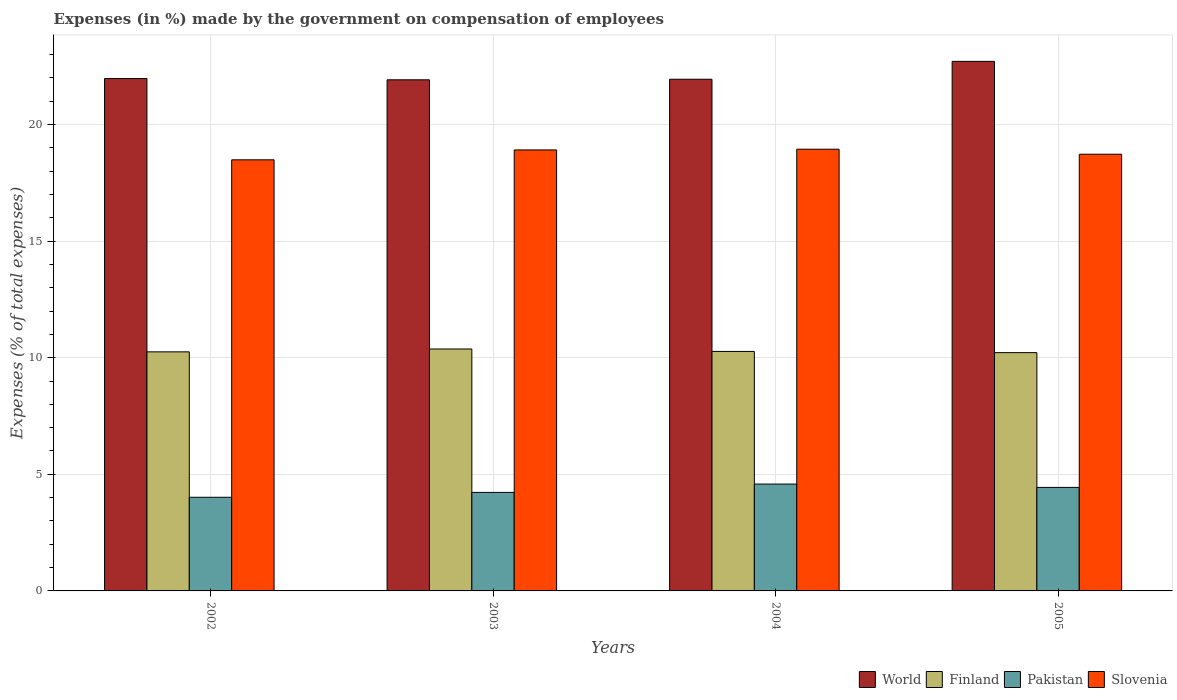How many different coloured bars are there?
Your answer should be compact. 4. Are the number of bars per tick equal to the number of legend labels?
Offer a very short reply. Yes. How many bars are there on the 4th tick from the right?
Offer a terse response. 4. What is the label of the 3rd group of bars from the left?
Keep it short and to the point. 2004. What is the percentage of expenses made by the government on compensation of employees in Finland in 2005?
Your answer should be compact. 10.22. Across all years, what is the maximum percentage of expenses made by the government on compensation of employees in Pakistan?
Give a very brief answer. 4.58. Across all years, what is the minimum percentage of expenses made by the government on compensation of employees in Slovenia?
Provide a succinct answer. 18.49. In which year was the percentage of expenses made by the government on compensation of employees in Finland minimum?
Offer a terse response. 2005. What is the total percentage of expenses made by the government on compensation of employees in Slovenia in the graph?
Your response must be concise. 75.06. What is the difference between the percentage of expenses made by the government on compensation of employees in Pakistan in 2003 and that in 2004?
Offer a terse response. -0.36. What is the difference between the percentage of expenses made by the government on compensation of employees in Pakistan in 2003 and the percentage of expenses made by the government on compensation of employees in Finland in 2005?
Offer a terse response. -5.99. What is the average percentage of expenses made by the government on compensation of employees in Pakistan per year?
Your answer should be compact. 4.32. In the year 2004, what is the difference between the percentage of expenses made by the government on compensation of employees in Slovenia and percentage of expenses made by the government on compensation of employees in Pakistan?
Your answer should be very brief. 14.36. What is the ratio of the percentage of expenses made by the government on compensation of employees in Slovenia in 2003 to that in 2004?
Offer a terse response. 1. Is the percentage of expenses made by the government on compensation of employees in Finland in 2004 less than that in 2005?
Your answer should be compact. No. Is the difference between the percentage of expenses made by the government on compensation of employees in Slovenia in 2003 and 2005 greater than the difference between the percentage of expenses made by the government on compensation of employees in Pakistan in 2003 and 2005?
Ensure brevity in your answer.  Yes. What is the difference between the highest and the second highest percentage of expenses made by the government on compensation of employees in Slovenia?
Your response must be concise. 0.03. What is the difference between the highest and the lowest percentage of expenses made by the government on compensation of employees in World?
Make the answer very short. 0.79. Is the sum of the percentage of expenses made by the government on compensation of employees in Pakistan in 2004 and 2005 greater than the maximum percentage of expenses made by the government on compensation of employees in Slovenia across all years?
Provide a short and direct response. No. Is it the case that in every year, the sum of the percentage of expenses made by the government on compensation of employees in Slovenia and percentage of expenses made by the government on compensation of employees in Finland is greater than the sum of percentage of expenses made by the government on compensation of employees in World and percentage of expenses made by the government on compensation of employees in Pakistan?
Provide a succinct answer. Yes. What does the 1st bar from the right in 2005 represents?
Your answer should be compact. Slovenia. Is it the case that in every year, the sum of the percentage of expenses made by the government on compensation of employees in World and percentage of expenses made by the government on compensation of employees in Pakistan is greater than the percentage of expenses made by the government on compensation of employees in Finland?
Make the answer very short. Yes. How many years are there in the graph?
Keep it short and to the point. 4. What is the difference between two consecutive major ticks on the Y-axis?
Ensure brevity in your answer.  5. Are the values on the major ticks of Y-axis written in scientific E-notation?
Your response must be concise. No. Does the graph contain grids?
Provide a succinct answer. Yes. Where does the legend appear in the graph?
Your answer should be very brief. Bottom right. How many legend labels are there?
Your answer should be compact. 4. What is the title of the graph?
Make the answer very short. Expenses (in %) made by the government on compensation of employees. Does "Kyrgyz Republic" appear as one of the legend labels in the graph?
Your answer should be compact. No. What is the label or title of the Y-axis?
Give a very brief answer. Expenses (% of total expenses). What is the Expenses (% of total expenses) in World in 2002?
Keep it short and to the point. 21.97. What is the Expenses (% of total expenses) in Finland in 2002?
Offer a very short reply. 10.25. What is the Expenses (% of total expenses) in Pakistan in 2002?
Offer a very short reply. 4.02. What is the Expenses (% of total expenses) in Slovenia in 2002?
Make the answer very short. 18.49. What is the Expenses (% of total expenses) of World in 2003?
Offer a terse response. 21.92. What is the Expenses (% of total expenses) in Finland in 2003?
Keep it short and to the point. 10.37. What is the Expenses (% of total expenses) in Pakistan in 2003?
Ensure brevity in your answer.  4.22. What is the Expenses (% of total expenses) of Slovenia in 2003?
Your response must be concise. 18.91. What is the Expenses (% of total expenses) of World in 2004?
Keep it short and to the point. 21.94. What is the Expenses (% of total expenses) of Finland in 2004?
Provide a succinct answer. 10.27. What is the Expenses (% of total expenses) of Pakistan in 2004?
Give a very brief answer. 4.58. What is the Expenses (% of total expenses) of Slovenia in 2004?
Your answer should be compact. 18.94. What is the Expenses (% of total expenses) of World in 2005?
Provide a succinct answer. 22.71. What is the Expenses (% of total expenses) in Finland in 2005?
Offer a terse response. 10.22. What is the Expenses (% of total expenses) of Pakistan in 2005?
Your answer should be compact. 4.44. What is the Expenses (% of total expenses) in Slovenia in 2005?
Give a very brief answer. 18.73. Across all years, what is the maximum Expenses (% of total expenses) of World?
Offer a very short reply. 22.71. Across all years, what is the maximum Expenses (% of total expenses) in Finland?
Offer a very short reply. 10.37. Across all years, what is the maximum Expenses (% of total expenses) of Pakistan?
Your answer should be compact. 4.58. Across all years, what is the maximum Expenses (% of total expenses) in Slovenia?
Offer a very short reply. 18.94. Across all years, what is the minimum Expenses (% of total expenses) in World?
Give a very brief answer. 21.92. Across all years, what is the minimum Expenses (% of total expenses) of Finland?
Offer a very short reply. 10.22. Across all years, what is the minimum Expenses (% of total expenses) of Pakistan?
Offer a very short reply. 4.02. Across all years, what is the minimum Expenses (% of total expenses) in Slovenia?
Make the answer very short. 18.49. What is the total Expenses (% of total expenses) of World in the graph?
Make the answer very short. 88.53. What is the total Expenses (% of total expenses) of Finland in the graph?
Ensure brevity in your answer.  41.11. What is the total Expenses (% of total expenses) of Pakistan in the graph?
Your answer should be very brief. 17.26. What is the total Expenses (% of total expenses) in Slovenia in the graph?
Make the answer very short. 75.06. What is the difference between the Expenses (% of total expenses) of World in 2002 and that in 2003?
Provide a short and direct response. 0.06. What is the difference between the Expenses (% of total expenses) of Finland in 2002 and that in 2003?
Make the answer very short. -0.12. What is the difference between the Expenses (% of total expenses) in Pakistan in 2002 and that in 2003?
Keep it short and to the point. -0.21. What is the difference between the Expenses (% of total expenses) of Slovenia in 2002 and that in 2003?
Provide a succinct answer. -0.42. What is the difference between the Expenses (% of total expenses) of World in 2002 and that in 2004?
Make the answer very short. 0.03. What is the difference between the Expenses (% of total expenses) of Finland in 2002 and that in 2004?
Offer a very short reply. -0.02. What is the difference between the Expenses (% of total expenses) of Pakistan in 2002 and that in 2004?
Offer a very short reply. -0.57. What is the difference between the Expenses (% of total expenses) in Slovenia in 2002 and that in 2004?
Provide a short and direct response. -0.45. What is the difference between the Expenses (% of total expenses) of World in 2002 and that in 2005?
Your answer should be compact. -0.74. What is the difference between the Expenses (% of total expenses) of Finland in 2002 and that in 2005?
Your answer should be very brief. 0.03. What is the difference between the Expenses (% of total expenses) in Pakistan in 2002 and that in 2005?
Your answer should be very brief. -0.42. What is the difference between the Expenses (% of total expenses) in Slovenia in 2002 and that in 2005?
Your answer should be very brief. -0.24. What is the difference between the Expenses (% of total expenses) of World in 2003 and that in 2004?
Give a very brief answer. -0.02. What is the difference between the Expenses (% of total expenses) of Finland in 2003 and that in 2004?
Provide a succinct answer. 0.11. What is the difference between the Expenses (% of total expenses) of Pakistan in 2003 and that in 2004?
Provide a succinct answer. -0.36. What is the difference between the Expenses (% of total expenses) of Slovenia in 2003 and that in 2004?
Keep it short and to the point. -0.03. What is the difference between the Expenses (% of total expenses) in World in 2003 and that in 2005?
Ensure brevity in your answer.  -0.79. What is the difference between the Expenses (% of total expenses) of Finland in 2003 and that in 2005?
Make the answer very short. 0.16. What is the difference between the Expenses (% of total expenses) in Pakistan in 2003 and that in 2005?
Give a very brief answer. -0.21. What is the difference between the Expenses (% of total expenses) of Slovenia in 2003 and that in 2005?
Give a very brief answer. 0.18. What is the difference between the Expenses (% of total expenses) of World in 2004 and that in 2005?
Your response must be concise. -0.77. What is the difference between the Expenses (% of total expenses) of Finland in 2004 and that in 2005?
Ensure brevity in your answer.  0.05. What is the difference between the Expenses (% of total expenses) in Pakistan in 2004 and that in 2005?
Your response must be concise. 0.14. What is the difference between the Expenses (% of total expenses) of Slovenia in 2004 and that in 2005?
Your response must be concise. 0.21. What is the difference between the Expenses (% of total expenses) in World in 2002 and the Expenses (% of total expenses) in Finland in 2003?
Keep it short and to the point. 11.6. What is the difference between the Expenses (% of total expenses) of World in 2002 and the Expenses (% of total expenses) of Pakistan in 2003?
Offer a terse response. 17.75. What is the difference between the Expenses (% of total expenses) in World in 2002 and the Expenses (% of total expenses) in Slovenia in 2003?
Give a very brief answer. 3.06. What is the difference between the Expenses (% of total expenses) of Finland in 2002 and the Expenses (% of total expenses) of Pakistan in 2003?
Ensure brevity in your answer.  6.03. What is the difference between the Expenses (% of total expenses) in Finland in 2002 and the Expenses (% of total expenses) in Slovenia in 2003?
Offer a very short reply. -8.66. What is the difference between the Expenses (% of total expenses) in Pakistan in 2002 and the Expenses (% of total expenses) in Slovenia in 2003?
Your answer should be very brief. -14.89. What is the difference between the Expenses (% of total expenses) of World in 2002 and the Expenses (% of total expenses) of Finland in 2004?
Keep it short and to the point. 11.7. What is the difference between the Expenses (% of total expenses) of World in 2002 and the Expenses (% of total expenses) of Pakistan in 2004?
Offer a very short reply. 17.39. What is the difference between the Expenses (% of total expenses) of World in 2002 and the Expenses (% of total expenses) of Slovenia in 2004?
Offer a terse response. 3.03. What is the difference between the Expenses (% of total expenses) in Finland in 2002 and the Expenses (% of total expenses) in Pakistan in 2004?
Give a very brief answer. 5.67. What is the difference between the Expenses (% of total expenses) of Finland in 2002 and the Expenses (% of total expenses) of Slovenia in 2004?
Offer a very short reply. -8.69. What is the difference between the Expenses (% of total expenses) in Pakistan in 2002 and the Expenses (% of total expenses) in Slovenia in 2004?
Ensure brevity in your answer.  -14.92. What is the difference between the Expenses (% of total expenses) of World in 2002 and the Expenses (% of total expenses) of Finland in 2005?
Ensure brevity in your answer.  11.75. What is the difference between the Expenses (% of total expenses) in World in 2002 and the Expenses (% of total expenses) in Pakistan in 2005?
Provide a succinct answer. 17.53. What is the difference between the Expenses (% of total expenses) in World in 2002 and the Expenses (% of total expenses) in Slovenia in 2005?
Your answer should be very brief. 3.25. What is the difference between the Expenses (% of total expenses) of Finland in 2002 and the Expenses (% of total expenses) of Pakistan in 2005?
Offer a very short reply. 5.81. What is the difference between the Expenses (% of total expenses) of Finland in 2002 and the Expenses (% of total expenses) of Slovenia in 2005?
Provide a succinct answer. -8.47. What is the difference between the Expenses (% of total expenses) in Pakistan in 2002 and the Expenses (% of total expenses) in Slovenia in 2005?
Your answer should be very brief. -14.71. What is the difference between the Expenses (% of total expenses) of World in 2003 and the Expenses (% of total expenses) of Finland in 2004?
Provide a short and direct response. 11.65. What is the difference between the Expenses (% of total expenses) in World in 2003 and the Expenses (% of total expenses) in Pakistan in 2004?
Ensure brevity in your answer.  17.33. What is the difference between the Expenses (% of total expenses) in World in 2003 and the Expenses (% of total expenses) in Slovenia in 2004?
Offer a terse response. 2.98. What is the difference between the Expenses (% of total expenses) of Finland in 2003 and the Expenses (% of total expenses) of Pakistan in 2004?
Provide a succinct answer. 5.79. What is the difference between the Expenses (% of total expenses) in Finland in 2003 and the Expenses (% of total expenses) in Slovenia in 2004?
Offer a terse response. -8.57. What is the difference between the Expenses (% of total expenses) in Pakistan in 2003 and the Expenses (% of total expenses) in Slovenia in 2004?
Offer a very short reply. -14.72. What is the difference between the Expenses (% of total expenses) of World in 2003 and the Expenses (% of total expenses) of Finland in 2005?
Offer a terse response. 11.7. What is the difference between the Expenses (% of total expenses) in World in 2003 and the Expenses (% of total expenses) in Pakistan in 2005?
Provide a succinct answer. 17.48. What is the difference between the Expenses (% of total expenses) of World in 2003 and the Expenses (% of total expenses) of Slovenia in 2005?
Provide a short and direct response. 3.19. What is the difference between the Expenses (% of total expenses) in Finland in 2003 and the Expenses (% of total expenses) in Pakistan in 2005?
Your answer should be compact. 5.94. What is the difference between the Expenses (% of total expenses) in Finland in 2003 and the Expenses (% of total expenses) in Slovenia in 2005?
Provide a succinct answer. -8.35. What is the difference between the Expenses (% of total expenses) in Pakistan in 2003 and the Expenses (% of total expenses) in Slovenia in 2005?
Offer a very short reply. -14.5. What is the difference between the Expenses (% of total expenses) in World in 2004 and the Expenses (% of total expenses) in Finland in 2005?
Provide a short and direct response. 11.72. What is the difference between the Expenses (% of total expenses) in World in 2004 and the Expenses (% of total expenses) in Pakistan in 2005?
Provide a succinct answer. 17.5. What is the difference between the Expenses (% of total expenses) of World in 2004 and the Expenses (% of total expenses) of Slovenia in 2005?
Ensure brevity in your answer.  3.21. What is the difference between the Expenses (% of total expenses) in Finland in 2004 and the Expenses (% of total expenses) in Pakistan in 2005?
Your answer should be compact. 5.83. What is the difference between the Expenses (% of total expenses) of Finland in 2004 and the Expenses (% of total expenses) of Slovenia in 2005?
Offer a very short reply. -8.46. What is the difference between the Expenses (% of total expenses) in Pakistan in 2004 and the Expenses (% of total expenses) in Slovenia in 2005?
Your answer should be very brief. -14.14. What is the average Expenses (% of total expenses) in World per year?
Provide a short and direct response. 22.13. What is the average Expenses (% of total expenses) in Finland per year?
Provide a succinct answer. 10.28. What is the average Expenses (% of total expenses) in Pakistan per year?
Ensure brevity in your answer.  4.32. What is the average Expenses (% of total expenses) in Slovenia per year?
Keep it short and to the point. 18.77. In the year 2002, what is the difference between the Expenses (% of total expenses) in World and Expenses (% of total expenses) in Finland?
Keep it short and to the point. 11.72. In the year 2002, what is the difference between the Expenses (% of total expenses) of World and Expenses (% of total expenses) of Pakistan?
Your answer should be very brief. 17.96. In the year 2002, what is the difference between the Expenses (% of total expenses) in World and Expenses (% of total expenses) in Slovenia?
Provide a short and direct response. 3.49. In the year 2002, what is the difference between the Expenses (% of total expenses) in Finland and Expenses (% of total expenses) in Pakistan?
Your response must be concise. 6.24. In the year 2002, what is the difference between the Expenses (% of total expenses) of Finland and Expenses (% of total expenses) of Slovenia?
Offer a very short reply. -8.23. In the year 2002, what is the difference between the Expenses (% of total expenses) in Pakistan and Expenses (% of total expenses) in Slovenia?
Ensure brevity in your answer.  -14.47. In the year 2003, what is the difference between the Expenses (% of total expenses) of World and Expenses (% of total expenses) of Finland?
Keep it short and to the point. 11.54. In the year 2003, what is the difference between the Expenses (% of total expenses) of World and Expenses (% of total expenses) of Pakistan?
Provide a short and direct response. 17.69. In the year 2003, what is the difference between the Expenses (% of total expenses) in World and Expenses (% of total expenses) in Slovenia?
Make the answer very short. 3.01. In the year 2003, what is the difference between the Expenses (% of total expenses) in Finland and Expenses (% of total expenses) in Pakistan?
Provide a short and direct response. 6.15. In the year 2003, what is the difference between the Expenses (% of total expenses) in Finland and Expenses (% of total expenses) in Slovenia?
Make the answer very short. -8.54. In the year 2003, what is the difference between the Expenses (% of total expenses) in Pakistan and Expenses (% of total expenses) in Slovenia?
Offer a terse response. -14.68. In the year 2004, what is the difference between the Expenses (% of total expenses) of World and Expenses (% of total expenses) of Finland?
Offer a terse response. 11.67. In the year 2004, what is the difference between the Expenses (% of total expenses) of World and Expenses (% of total expenses) of Pakistan?
Give a very brief answer. 17.36. In the year 2004, what is the difference between the Expenses (% of total expenses) of World and Expenses (% of total expenses) of Slovenia?
Your response must be concise. 3. In the year 2004, what is the difference between the Expenses (% of total expenses) of Finland and Expenses (% of total expenses) of Pakistan?
Offer a terse response. 5.69. In the year 2004, what is the difference between the Expenses (% of total expenses) in Finland and Expenses (% of total expenses) in Slovenia?
Offer a very short reply. -8.67. In the year 2004, what is the difference between the Expenses (% of total expenses) in Pakistan and Expenses (% of total expenses) in Slovenia?
Offer a terse response. -14.36. In the year 2005, what is the difference between the Expenses (% of total expenses) of World and Expenses (% of total expenses) of Finland?
Offer a very short reply. 12.49. In the year 2005, what is the difference between the Expenses (% of total expenses) of World and Expenses (% of total expenses) of Pakistan?
Provide a short and direct response. 18.27. In the year 2005, what is the difference between the Expenses (% of total expenses) of World and Expenses (% of total expenses) of Slovenia?
Your answer should be compact. 3.98. In the year 2005, what is the difference between the Expenses (% of total expenses) of Finland and Expenses (% of total expenses) of Pakistan?
Offer a terse response. 5.78. In the year 2005, what is the difference between the Expenses (% of total expenses) of Finland and Expenses (% of total expenses) of Slovenia?
Make the answer very short. -8.51. In the year 2005, what is the difference between the Expenses (% of total expenses) in Pakistan and Expenses (% of total expenses) in Slovenia?
Your answer should be compact. -14.29. What is the ratio of the Expenses (% of total expenses) in World in 2002 to that in 2003?
Make the answer very short. 1. What is the ratio of the Expenses (% of total expenses) in Finland in 2002 to that in 2003?
Keep it short and to the point. 0.99. What is the ratio of the Expenses (% of total expenses) of Pakistan in 2002 to that in 2003?
Your response must be concise. 0.95. What is the ratio of the Expenses (% of total expenses) of Slovenia in 2002 to that in 2003?
Offer a very short reply. 0.98. What is the ratio of the Expenses (% of total expenses) in Finland in 2002 to that in 2004?
Make the answer very short. 1. What is the ratio of the Expenses (% of total expenses) of Pakistan in 2002 to that in 2004?
Make the answer very short. 0.88. What is the ratio of the Expenses (% of total expenses) in World in 2002 to that in 2005?
Your answer should be very brief. 0.97. What is the ratio of the Expenses (% of total expenses) in Pakistan in 2002 to that in 2005?
Keep it short and to the point. 0.9. What is the ratio of the Expenses (% of total expenses) of Slovenia in 2002 to that in 2005?
Your answer should be very brief. 0.99. What is the ratio of the Expenses (% of total expenses) in World in 2003 to that in 2004?
Your answer should be very brief. 1. What is the ratio of the Expenses (% of total expenses) of Finland in 2003 to that in 2004?
Your response must be concise. 1.01. What is the ratio of the Expenses (% of total expenses) in Pakistan in 2003 to that in 2004?
Make the answer very short. 0.92. What is the ratio of the Expenses (% of total expenses) in World in 2003 to that in 2005?
Make the answer very short. 0.97. What is the ratio of the Expenses (% of total expenses) of Finland in 2003 to that in 2005?
Keep it short and to the point. 1.02. What is the ratio of the Expenses (% of total expenses) of Pakistan in 2003 to that in 2005?
Keep it short and to the point. 0.95. What is the ratio of the Expenses (% of total expenses) in Slovenia in 2003 to that in 2005?
Provide a succinct answer. 1.01. What is the ratio of the Expenses (% of total expenses) in World in 2004 to that in 2005?
Make the answer very short. 0.97. What is the ratio of the Expenses (% of total expenses) of Finland in 2004 to that in 2005?
Provide a short and direct response. 1. What is the ratio of the Expenses (% of total expenses) of Pakistan in 2004 to that in 2005?
Keep it short and to the point. 1.03. What is the ratio of the Expenses (% of total expenses) of Slovenia in 2004 to that in 2005?
Offer a very short reply. 1.01. What is the difference between the highest and the second highest Expenses (% of total expenses) in World?
Provide a short and direct response. 0.74. What is the difference between the highest and the second highest Expenses (% of total expenses) of Finland?
Provide a succinct answer. 0.11. What is the difference between the highest and the second highest Expenses (% of total expenses) of Pakistan?
Provide a succinct answer. 0.14. What is the difference between the highest and the second highest Expenses (% of total expenses) of Slovenia?
Your answer should be compact. 0.03. What is the difference between the highest and the lowest Expenses (% of total expenses) in World?
Keep it short and to the point. 0.79. What is the difference between the highest and the lowest Expenses (% of total expenses) of Finland?
Provide a succinct answer. 0.16. What is the difference between the highest and the lowest Expenses (% of total expenses) in Pakistan?
Offer a very short reply. 0.57. What is the difference between the highest and the lowest Expenses (% of total expenses) of Slovenia?
Offer a very short reply. 0.45. 